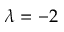Convert formula to latex. <formula><loc_0><loc_0><loc_500><loc_500>\lambda = - 2</formula> 